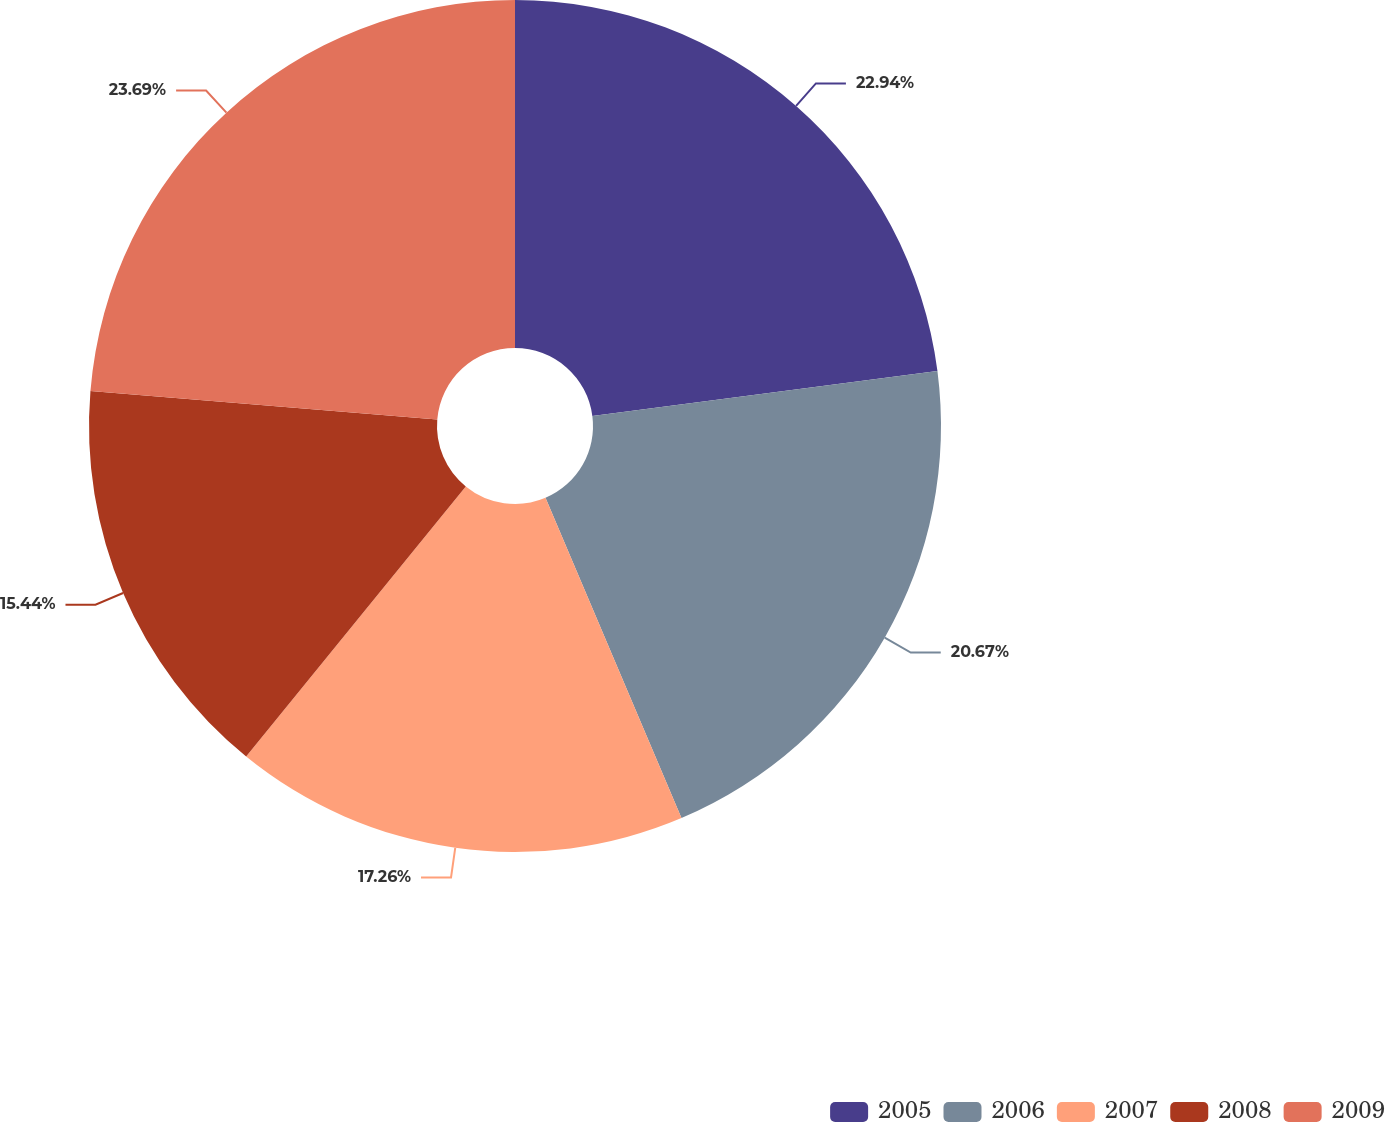<chart> <loc_0><loc_0><loc_500><loc_500><pie_chart><fcel>2005<fcel>2006<fcel>2007<fcel>2008<fcel>2009<nl><fcel>22.94%<fcel>20.67%<fcel>17.26%<fcel>15.44%<fcel>23.69%<nl></chart> 